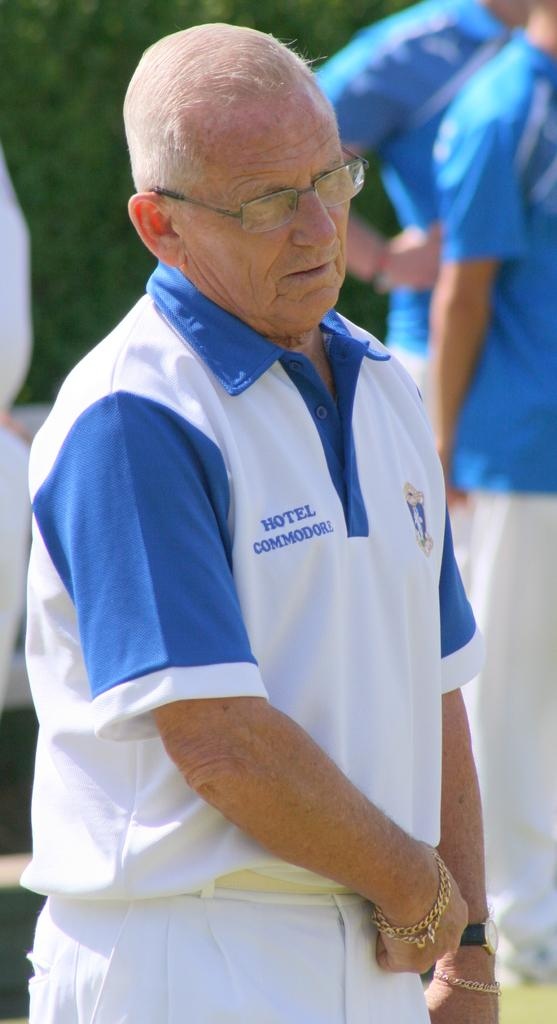Who is the main subject in the image? There is a man in the image. What is the man wearing? The man is wearing a white and blue t-shirt. Are there any other people in the image? Yes, there are people standing behind the man. What can be seen in the background of the image? There are trees visible in the image. What type of ant can be seen crawling on the man's t-shirt in the image? There are no ants visible in the image, and therefore no such activity can be observed. 